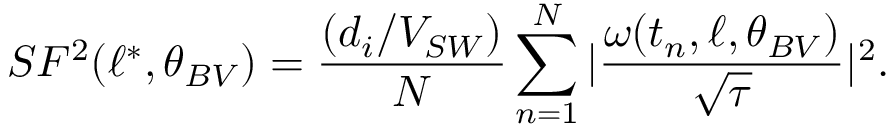Convert formula to latex. <formula><loc_0><loc_0><loc_500><loc_500>S F ^ { 2 } ( \ell ^ { \ast } , \theta _ { B V } ) = \frac { ( d _ { i } / V _ { S W } ) } { N } \sum _ { n = 1 } ^ { N } | \frac { \omega ( t _ { n } , \ell , \theta _ { B V } ) } { \sqrt { \tau } } | ^ { 2 } .</formula> 